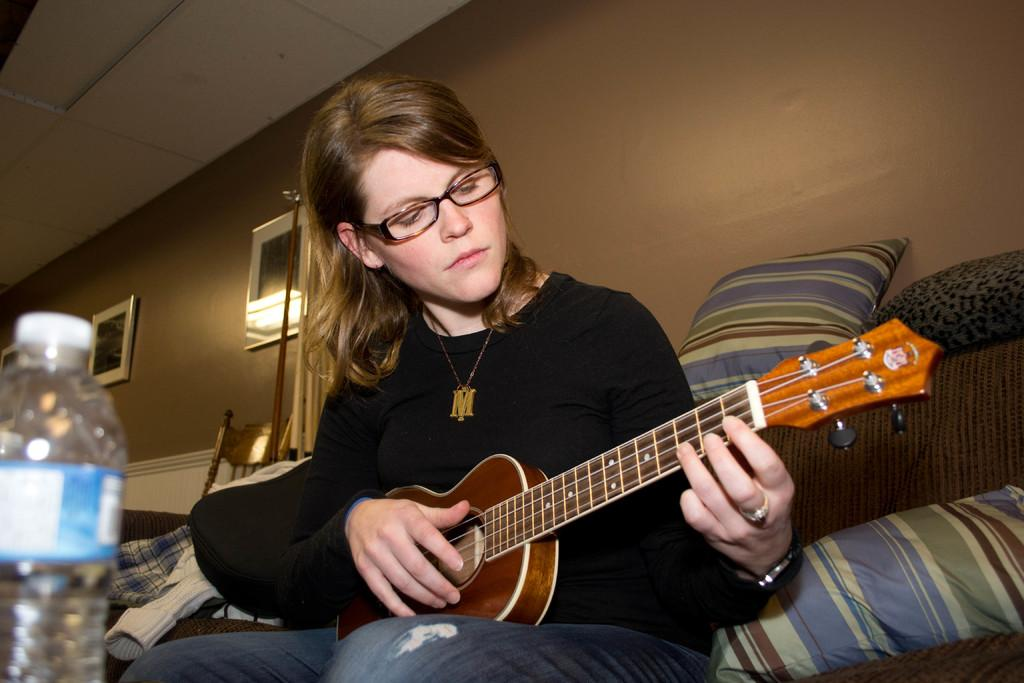Who is the main subject in the image? There is a lady in the image. What is the lady doing in the image? The lady is sitting on a sofa and playing a guitar. What else can be seen on the sofa? There is a bottle and some pillows on the sofa. What can be seen in the background of the image? There are chairs and photo frames on the wall in the background. What type of boat can be seen in the image? There is no boat present in the image. 